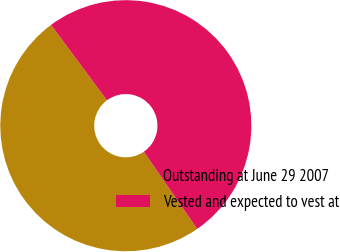<chart> <loc_0><loc_0><loc_500><loc_500><pie_chart><fcel>Outstanding at June 29 2007<fcel>Vested and expected to vest at<nl><fcel>49.47%<fcel>50.53%<nl></chart> 